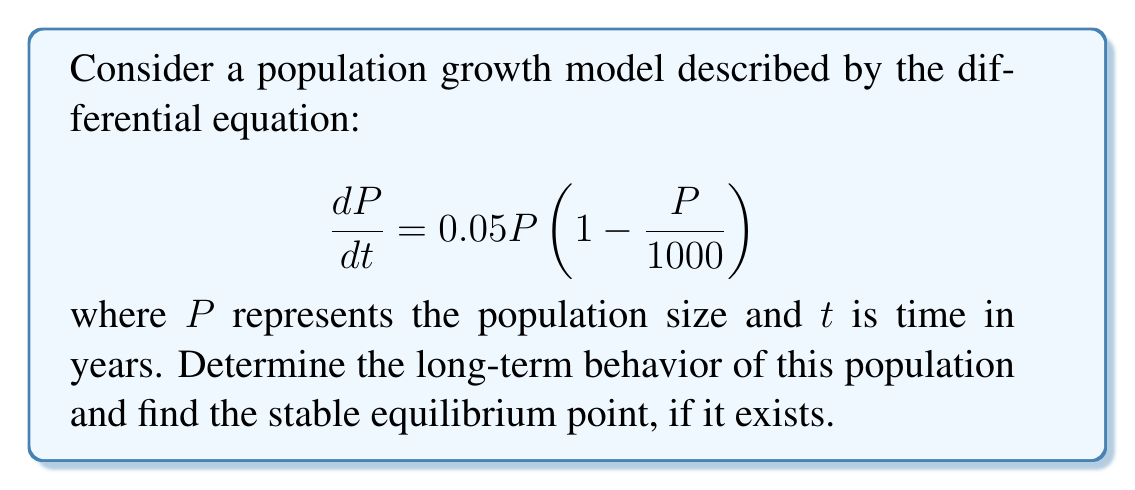What is the answer to this math problem? To analyze the long-term behavior of this population growth model, we'll follow these steps:

1) First, let's identify the equilibrium points by setting $\frac{dP}{dt} = 0$:

   $$0.05P\left(1 - \frac{P}{1000}\right) = 0$$

2) Solving this equation:
   - $P = 0$ is one solution
   - $1 - \frac{P}{1000} = 0$ gives $P = 1000$ as another solution

3) Now, let's analyze the stability of these equilibrium points:

   For $P = 0$:
   $$\left.\frac{d}{dP}\left(0.05P\left(1 - \frac{P}{1000}\right)\right)\right|_{P=0} = 0.05 > 0$$
   This indicates that $P = 0$ is an unstable equilibrium.

   For $P = 1000$:
   $$\left.\frac{d}{dP}\left(0.05P\left(1 - \frac{P}{1000}\right)\right)\right|_{P=1000} = -0.05 < 0$$
   This indicates that $P = 1000$ is a stable equilibrium.

4) Interpreting the results:
   - If $P < 1000$, the population will grow towards 1000
   - If $P > 1000$, the population will decrease towards 1000

5) Therefore, in the long term, regardless of the initial population size (as long as it's not exactly 0), the population will approach 1000.

This model is known as the logistic growth model, where 1000 represents the carrying capacity of the environment.
Answer: The population will stabilize at 1000 individuals in the long term. 